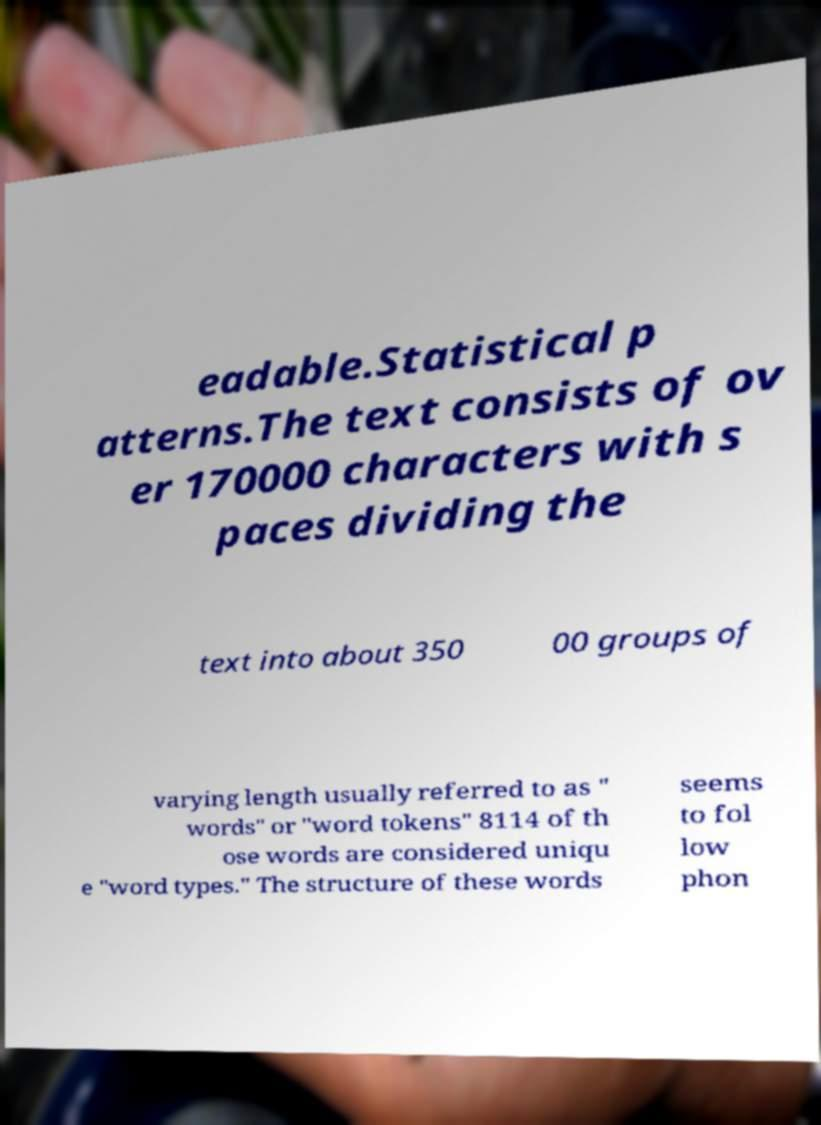What messages or text are displayed in this image? I need them in a readable, typed format. eadable.Statistical p atterns.The text consists of ov er 170000 characters with s paces dividing the text into about 350 00 groups of varying length usually referred to as " words" or "word tokens" 8114 of th ose words are considered uniqu e "word types." The structure of these words seems to fol low phon 